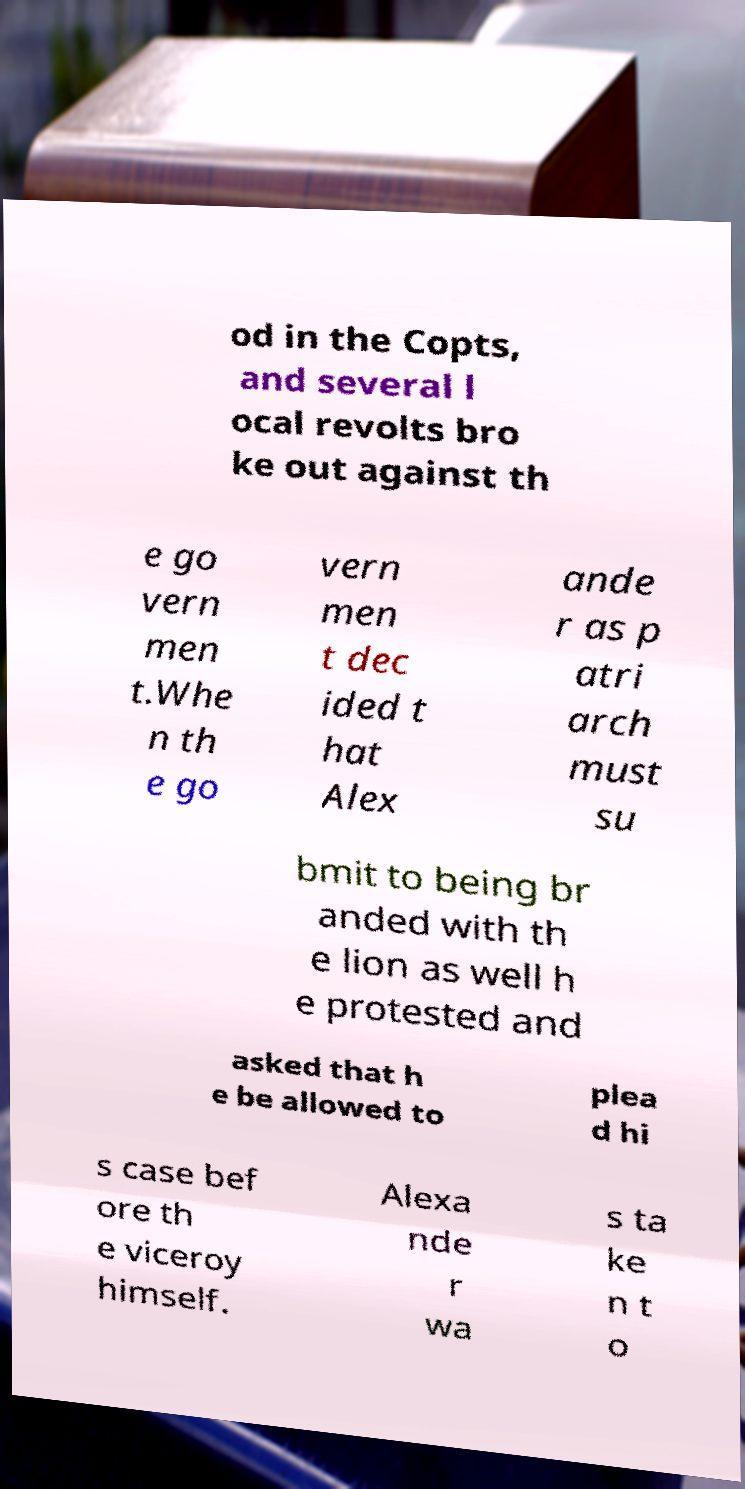Could you extract and type out the text from this image? od in the Copts, and several l ocal revolts bro ke out against th e go vern men t.Whe n th e go vern men t dec ided t hat Alex ande r as p atri arch must su bmit to being br anded with th e lion as well h e protested and asked that h e be allowed to plea d hi s case bef ore th e viceroy himself. Alexa nde r wa s ta ke n t o 